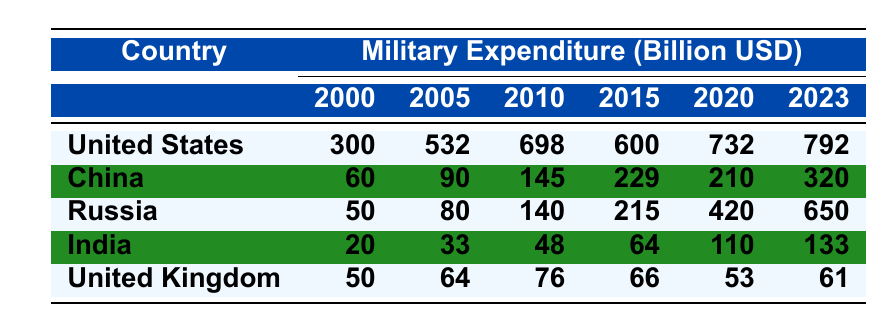What was the military expenditure of the United States in 2020? The table shows that the military expenditure of the United States in 2020 was 732 billion USD as per the data provided.
Answer: 732 billion USD Which country had the highest military expenditure in 2023? The table indicates that in 2023, the United States had the highest military expenditure at 792 billion USD, more than any other country.
Answer: United States How much did China's military expenditure increase from 2010 to 2023? China's military expenditure in 2010 was 145 billion USD, and in 2023 it was 320 billion USD. Thus, the increase is 320 - 145 = 175 billion USD.
Answer: 175 billion USD What was the average military expenditure of Russia from 2000 to 2023? To find the average, we sum the expenditures from each year: (50 + 80 + 140 + 215 + 420 + 650) = 1555 billion USD. There are 6 data points (2000, 2005, 2010, 2015, 2020, 2023), so the average is 1555 / 6 = 259.16 billion USD.
Answer: Approximately 259.16 billion USD Is India's military expenditure in 2023 greater than that of the United Kingdom? In 2023, India's military expenditure is 133 billion USD and the United Kingdom's is 61 billion USD. Since 133 is greater than 61, the answer is yes.
Answer: Yes Which country had the smallest military expenditure in 2000, and what was the amount? The table shows that in 2000, India's military expenditure was the smallest at 20 billion USD.
Answer: India, 20 billion USD What overall trend can be observed in military expenditures of the United States from 2000 to 2023? By examining the values in the table, it can be seen that the expenditures generally increased over the years, with a notable decrease in 2012 and then a gradual rise again until 2023.
Answer: Generally increasing trend with a decrease in 2012 How does the military expenditure of Russia in 2022 compare to its expenditure in 2020? In 2020, Russia's military expenditure was 420 billion USD and in 2022 it was 600 billion USD. Therefore, the 2022 expenditure is higher by 600 - 420 = 180 billion USD.
Answer: Higher by 180 billion USD What is the difference between the military expenditures of the United States and China in 2023? The military expenditures in 2023 were 792 billion USD for the United States and 320 billion USD for China, so the difference is 792 - 320 = 472 billion USD.
Answer: 472 billion USD Which country showed a decrease in military expenditure from 2015 to 2020? The table shows that the United Kingdom decreased its military expenditure from 66 billion USD in 2015 to 53 billion USD in 2020, indicating a reduction.
Answer: United Kingdom 